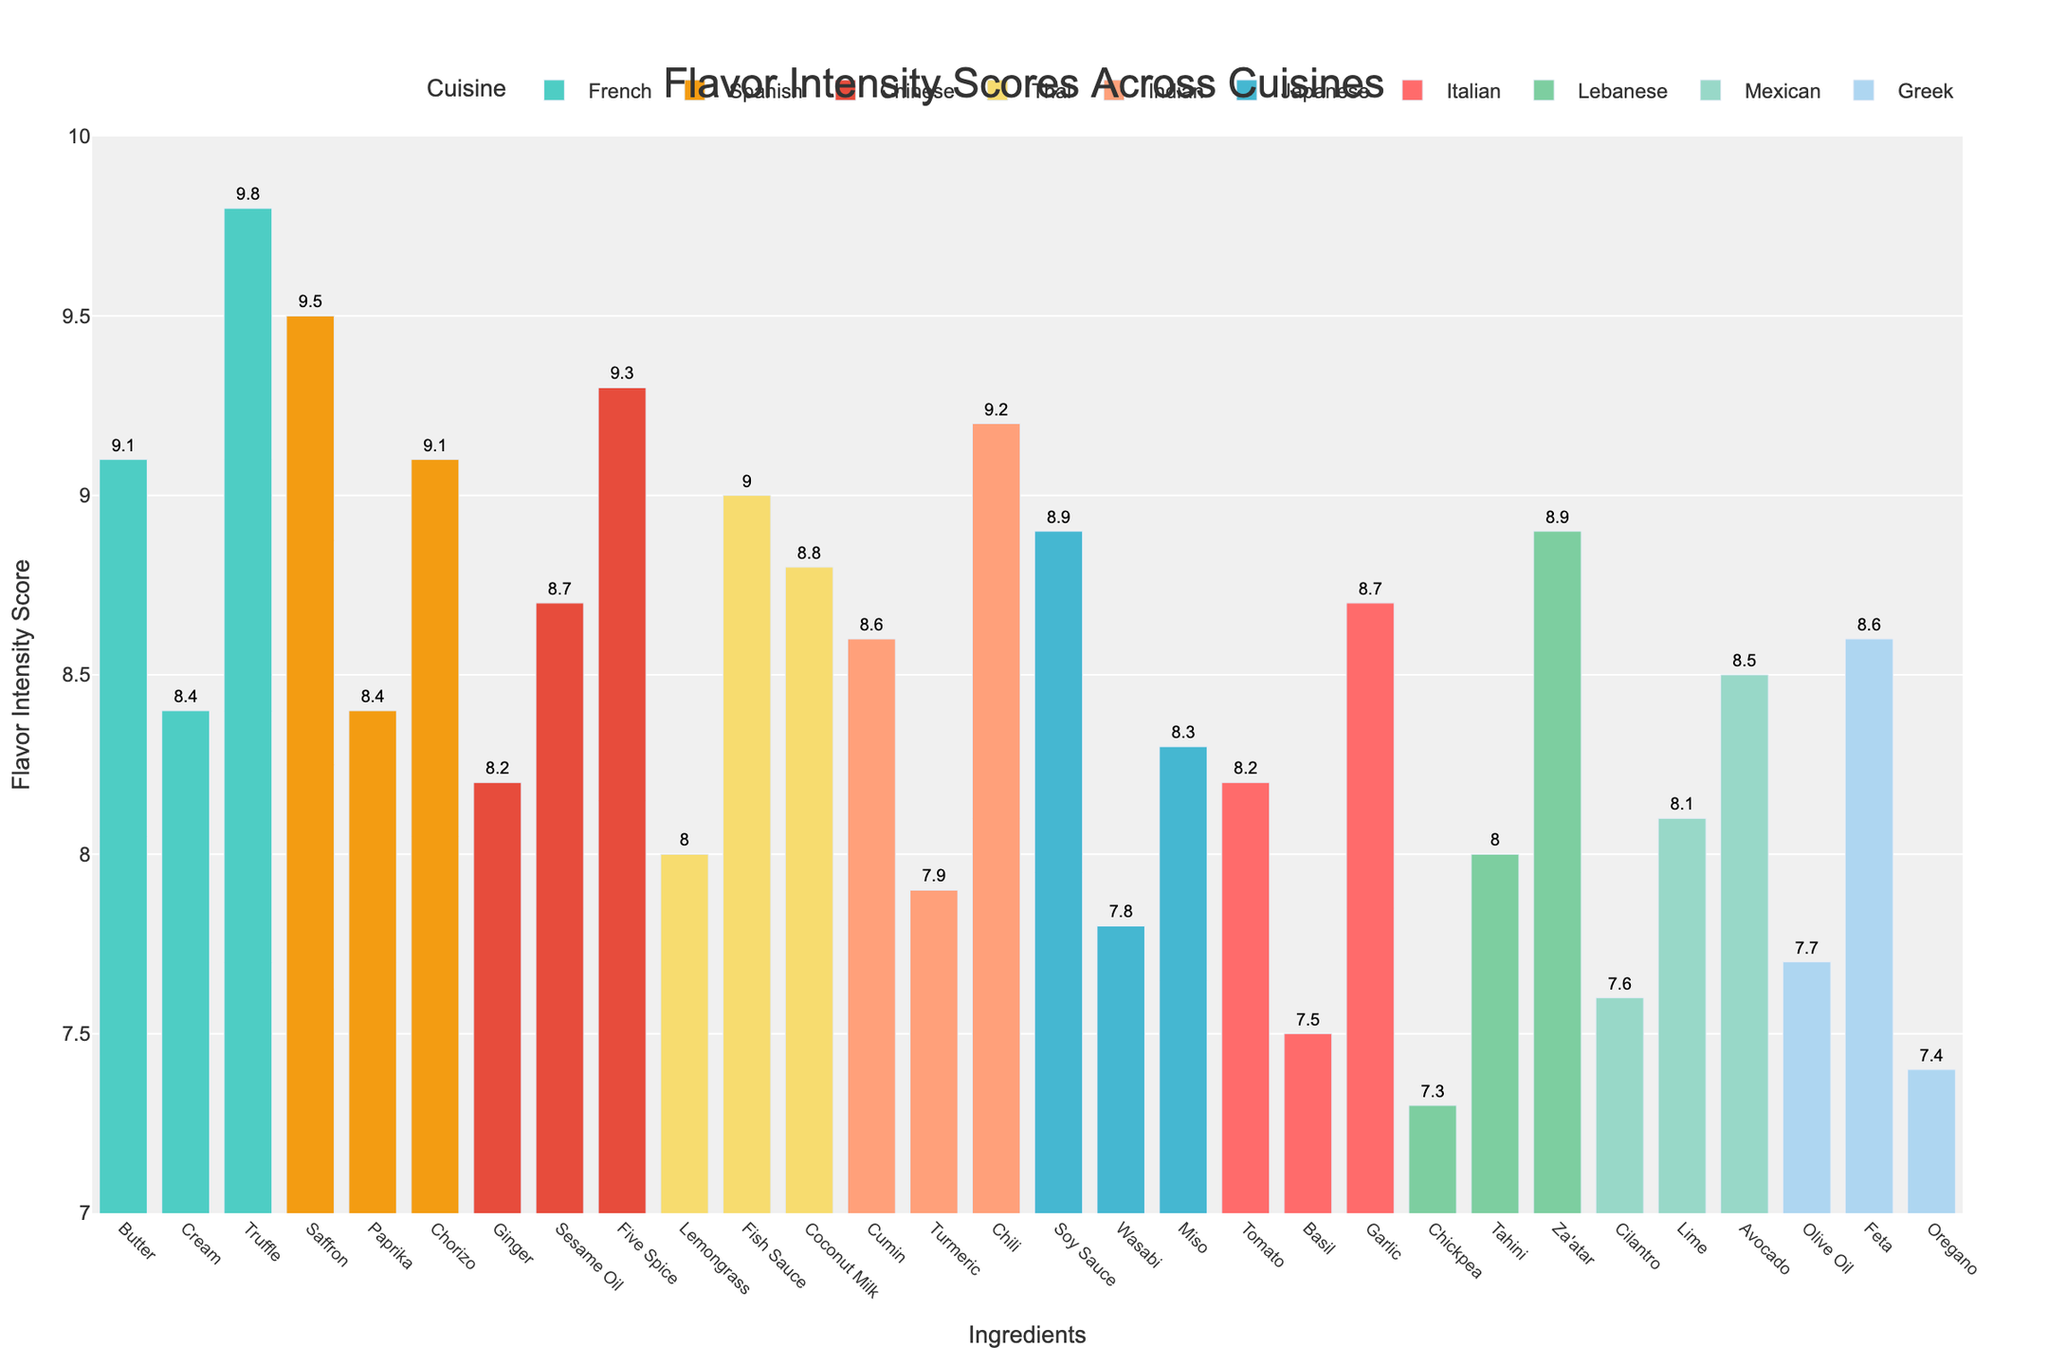What's the title of the figure? The title is located at the top center of the plot and it is "Flavor Intensity Scores Across Cuisines".
Answer: Flavor Intensity Scores Across Cuisines Which cuisine has the highest flavor intensity score for a single ingredient? The highest flavor intensity score for a single ingredient can be observed at the peak of the tallest bar. The French cuisine ingredient 'Truffle' has the highest score of 9.8.
Answer: French (Truffle, 9.8) What is the average flavor intensity score for Greek cuisine? To find the average, look at all the flavor intensity scores for Greek cuisine: Olive Oil (7.7), Feta (8.6), and Oregano (7.4). Sum them up: 7.7 + 8.6 + 7.4 = 23.7, then divide by the number of ingredients (3): 23.7 / 3 = 7.9.
Answer: 7.9 Which two cuisines have the most similar average flavor intensity scores? First, calculate the average score for each cuisine. Then, compare these averages to find the pair with the minimal difference. Italian (8.13), French (9.1), Japanese (8.33), Indian (8.57), Mexican (8.07), Thai (8.60), Greek (7.9), Chinese (8.73), Spanish (9.0), Lebanese (8.07). The cuisines with the closest averages are Mexican and Lebanese (both 8.07).
Answer: Mexican and Lebanese Which ingredient in Japanese cuisine has the highest flavor intensity score? Identify the bars specifically labeled for Japanese cuisine. Among these, Soy Sauce has the highest flavor intensity score of 8.9.
Answer: Soy Sauce (8.9) How many ingredients from Spanish cuisine have a flavor intensity score higher than 8.5? For Spanish cuisine, check each bar: Saffron (9.5), Paprika (8.4), Chorizo (9.1). Only Saffron and Chorizo have scores greater than 8.5.
Answer: 2 What is the difference in flavor intensity score between the highest-ranking ingredient in Chinese cuisine and the highest-ranking ingredient in Indian cuisine? The highest-ranking ingredient for Chinese cuisine is Five Spice with a score of 9.3, and for Indian cuisine, it is Chili with a score of 9.2. The difference is 9.3 - 9.2 = 0.1.
Answer: 0.1 Which cuisine has the widest range of flavor intensity scores? Check the range (difference between highest and lowest scores) for each cuisine. French: 9.8 (Truffle) - 8.4 (Cream) = 1.4, Indian: 9.2 (Chili) - 7.9 (Turmeric) = 1.3. French has the widest range.
Answer: French Which ingredient in the Mexican cuisine has the lowest flavor intensity score? Among the Mexican cuisine bars, Cilantro has the lowest score of 7.6.
Answer: Cilantro (7.6) 